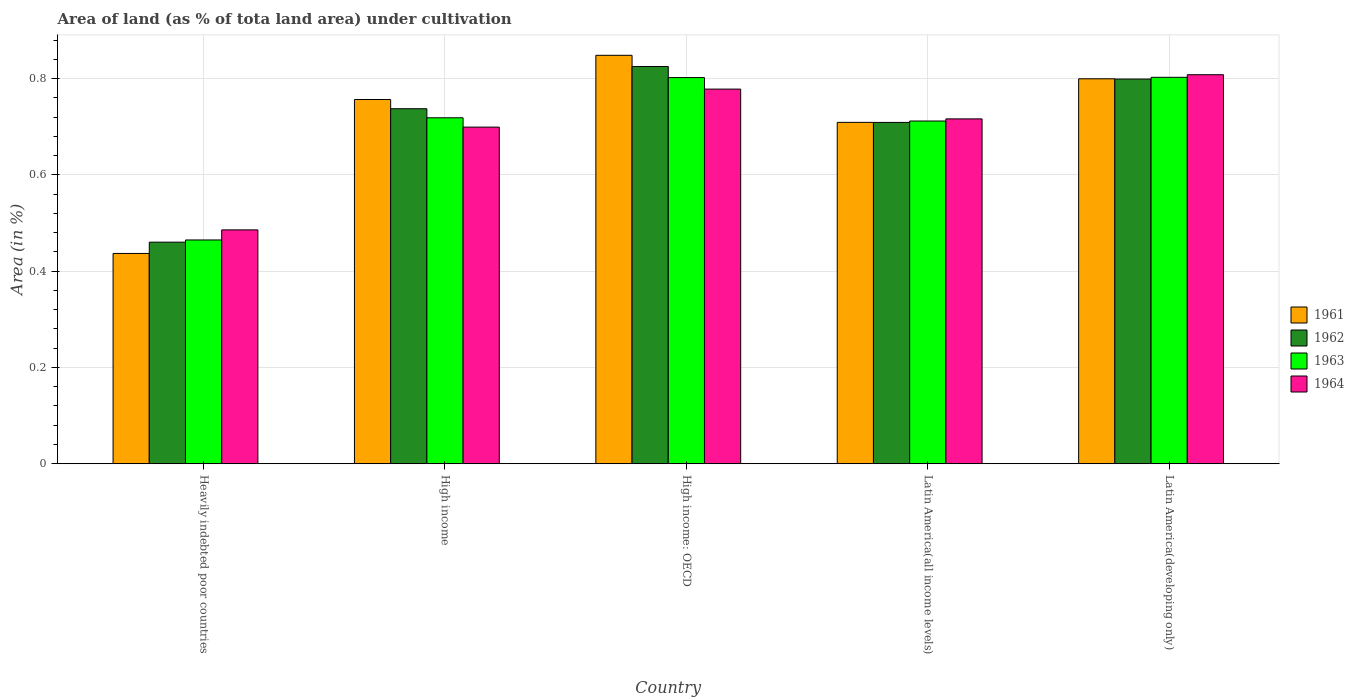How many different coloured bars are there?
Keep it short and to the point. 4. How many groups of bars are there?
Provide a short and direct response. 5. Are the number of bars on each tick of the X-axis equal?
Your answer should be very brief. Yes. What is the label of the 1st group of bars from the left?
Ensure brevity in your answer.  Heavily indebted poor countries. What is the percentage of land under cultivation in 1963 in Latin America(all income levels)?
Keep it short and to the point. 0.71. Across all countries, what is the maximum percentage of land under cultivation in 1961?
Your response must be concise. 0.85. Across all countries, what is the minimum percentage of land under cultivation in 1961?
Provide a short and direct response. 0.44. In which country was the percentage of land under cultivation in 1962 maximum?
Give a very brief answer. High income: OECD. In which country was the percentage of land under cultivation in 1961 minimum?
Offer a terse response. Heavily indebted poor countries. What is the total percentage of land under cultivation in 1961 in the graph?
Offer a very short reply. 3.55. What is the difference between the percentage of land under cultivation in 1964 in High income: OECD and that in Latin America(all income levels)?
Provide a succinct answer. 0.06. What is the difference between the percentage of land under cultivation in 1963 in High income and the percentage of land under cultivation in 1961 in Latin America(all income levels)?
Keep it short and to the point. 0.01. What is the average percentage of land under cultivation in 1963 per country?
Offer a very short reply. 0.7. What is the difference between the percentage of land under cultivation of/in 1961 and percentage of land under cultivation of/in 1962 in Latin America(all income levels)?
Provide a short and direct response. 9.965587828697497e-5. In how many countries, is the percentage of land under cultivation in 1962 greater than 0.08 %?
Provide a succinct answer. 5. What is the ratio of the percentage of land under cultivation in 1961 in Latin America(all income levels) to that in Latin America(developing only)?
Offer a very short reply. 0.89. Is the percentage of land under cultivation in 1962 in High income less than that in Latin America(developing only)?
Offer a terse response. Yes. Is the difference between the percentage of land under cultivation in 1961 in Heavily indebted poor countries and High income greater than the difference between the percentage of land under cultivation in 1962 in Heavily indebted poor countries and High income?
Give a very brief answer. No. What is the difference between the highest and the second highest percentage of land under cultivation in 1963?
Keep it short and to the point. 0. What is the difference between the highest and the lowest percentage of land under cultivation in 1963?
Make the answer very short. 0.34. What does the 2nd bar from the left in High income: OECD represents?
Provide a succinct answer. 1962. What does the 2nd bar from the right in Latin America(developing only) represents?
Give a very brief answer. 1963. How many bars are there?
Your response must be concise. 20. Are all the bars in the graph horizontal?
Your answer should be very brief. No. How many countries are there in the graph?
Give a very brief answer. 5. What is the difference between two consecutive major ticks on the Y-axis?
Offer a terse response. 0.2. Are the values on the major ticks of Y-axis written in scientific E-notation?
Provide a succinct answer. No. Does the graph contain any zero values?
Your response must be concise. No. Does the graph contain grids?
Your answer should be very brief. Yes. Where does the legend appear in the graph?
Provide a succinct answer. Center right. How many legend labels are there?
Offer a terse response. 4. How are the legend labels stacked?
Offer a terse response. Vertical. What is the title of the graph?
Keep it short and to the point. Area of land (as % of tota land area) under cultivation. What is the label or title of the X-axis?
Ensure brevity in your answer.  Country. What is the label or title of the Y-axis?
Offer a very short reply. Area (in %). What is the Area (in %) of 1961 in Heavily indebted poor countries?
Ensure brevity in your answer.  0.44. What is the Area (in %) in 1962 in Heavily indebted poor countries?
Your answer should be compact. 0.46. What is the Area (in %) in 1963 in Heavily indebted poor countries?
Make the answer very short. 0.46. What is the Area (in %) of 1964 in Heavily indebted poor countries?
Make the answer very short. 0.49. What is the Area (in %) in 1961 in High income?
Offer a very short reply. 0.76. What is the Area (in %) in 1962 in High income?
Provide a succinct answer. 0.74. What is the Area (in %) in 1963 in High income?
Make the answer very short. 0.72. What is the Area (in %) in 1964 in High income?
Ensure brevity in your answer.  0.7. What is the Area (in %) of 1961 in High income: OECD?
Make the answer very short. 0.85. What is the Area (in %) in 1962 in High income: OECD?
Offer a very short reply. 0.83. What is the Area (in %) of 1963 in High income: OECD?
Keep it short and to the point. 0.8. What is the Area (in %) in 1964 in High income: OECD?
Keep it short and to the point. 0.78. What is the Area (in %) in 1961 in Latin America(all income levels)?
Give a very brief answer. 0.71. What is the Area (in %) of 1962 in Latin America(all income levels)?
Provide a succinct answer. 0.71. What is the Area (in %) in 1963 in Latin America(all income levels)?
Your answer should be compact. 0.71. What is the Area (in %) of 1964 in Latin America(all income levels)?
Your response must be concise. 0.72. What is the Area (in %) of 1961 in Latin America(developing only)?
Provide a succinct answer. 0.8. What is the Area (in %) in 1962 in Latin America(developing only)?
Make the answer very short. 0.8. What is the Area (in %) of 1963 in Latin America(developing only)?
Ensure brevity in your answer.  0.8. What is the Area (in %) of 1964 in Latin America(developing only)?
Offer a very short reply. 0.81. Across all countries, what is the maximum Area (in %) of 1961?
Your answer should be very brief. 0.85. Across all countries, what is the maximum Area (in %) of 1962?
Your answer should be very brief. 0.83. Across all countries, what is the maximum Area (in %) in 1963?
Your response must be concise. 0.8. Across all countries, what is the maximum Area (in %) of 1964?
Offer a terse response. 0.81. Across all countries, what is the minimum Area (in %) of 1961?
Your answer should be very brief. 0.44. Across all countries, what is the minimum Area (in %) of 1962?
Offer a terse response. 0.46. Across all countries, what is the minimum Area (in %) of 1963?
Ensure brevity in your answer.  0.46. Across all countries, what is the minimum Area (in %) in 1964?
Offer a very short reply. 0.49. What is the total Area (in %) in 1961 in the graph?
Ensure brevity in your answer.  3.55. What is the total Area (in %) in 1962 in the graph?
Make the answer very short. 3.53. What is the total Area (in %) in 1964 in the graph?
Offer a terse response. 3.49. What is the difference between the Area (in %) of 1961 in Heavily indebted poor countries and that in High income?
Your answer should be very brief. -0.32. What is the difference between the Area (in %) of 1962 in Heavily indebted poor countries and that in High income?
Make the answer very short. -0.28. What is the difference between the Area (in %) in 1963 in Heavily indebted poor countries and that in High income?
Your answer should be very brief. -0.25. What is the difference between the Area (in %) in 1964 in Heavily indebted poor countries and that in High income?
Your answer should be compact. -0.21. What is the difference between the Area (in %) in 1961 in Heavily indebted poor countries and that in High income: OECD?
Ensure brevity in your answer.  -0.41. What is the difference between the Area (in %) in 1962 in Heavily indebted poor countries and that in High income: OECD?
Offer a very short reply. -0.36. What is the difference between the Area (in %) in 1963 in Heavily indebted poor countries and that in High income: OECD?
Make the answer very short. -0.34. What is the difference between the Area (in %) in 1964 in Heavily indebted poor countries and that in High income: OECD?
Ensure brevity in your answer.  -0.29. What is the difference between the Area (in %) in 1961 in Heavily indebted poor countries and that in Latin America(all income levels)?
Offer a very short reply. -0.27. What is the difference between the Area (in %) of 1962 in Heavily indebted poor countries and that in Latin America(all income levels)?
Offer a terse response. -0.25. What is the difference between the Area (in %) of 1963 in Heavily indebted poor countries and that in Latin America(all income levels)?
Provide a succinct answer. -0.25. What is the difference between the Area (in %) in 1964 in Heavily indebted poor countries and that in Latin America(all income levels)?
Offer a very short reply. -0.23. What is the difference between the Area (in %) of 1961 in Heavily indebted poor countries and that in Latin America(developing only)?
Offer a very short reply. -0.36. What is the difference between the Area (in %) in 1962 in Heavily indebted poor countries and that in Latin America(developing only)?
Your answer should be very brief. -0.34. What is the difference between the Area (in %) in 1963 in Heavily indebted poor countries and that in Latin America(developing only)?
Provide a succinct answer. -0.34. What is the difference between the Area (in %) in 1964 in Heavily indebted poor countries and that in Latin America(developing only)?
Make the answer very short. -0.32. What is the difference between the Area (in %) of 1961 in High income and that in High income: OECD?
Keep it short and to the point. -0.09. What is the difference between the Area (in %) of 1962 in High income and that in High income: OECD?
Ensure brevity in your answer.  -0.09. What is the difference between the Area (in %) in 1963 in High income and that in High income: OECD?
Your answer should be very brief. -0.08. What is the difference between the Area (in %) of 1964 in High income and that in High income: OECD?
Provide a succinct answer. -0.08. What is the difference between the Area (in %) in 1961 in High income and that in Latin America(all income levels)?
Offer a terse response. 0.05. What is the difference between the Area (in %) of 1962 in High income and that in Latin America(all income levels)?
Keep it short and to the point. 0.03. What is the difference between the Area (in %) of 1963 in High income and that in Latin America(all income levels)?
Your response must be concise. 0.01. What is the difference between the Area (in %) of 1964 in High income and that in Latin America(all income levels)?
Your answer should be compact. -0.02. What is the difference between the Area (in %) in 1961 in High income and that in Latin America(developing only)?
Offer a terse response. -0.04. What is the difference between the Area (in %) in 1962 in High income and that in Latin America(developing only)?
Offer a terse response. -0.06. What is the difference between the Area (in %) of 1963 in High income and that in Latin America(developing only)?
Your response must be concise. -0.08. What is the difference between the Area (in %) in 1964 in High income and that in Latin America(developing only)?
Provide a short and direct response. -0.11. What is the difference between the Area (in %) in 1961 in High income: OECD and that in Latin America(all income levels)?
Offer a very short reply. 0.14. What is the difference between the Area (in %) of 1962 in High income: OECD and that in Latin America(all income levels)?
Give a very brief answer. 0.12. What is the difference between the Area (in %) in 1963 in High income: OECD and that in Latin America(all income levels)?
Your response must be concise. 0.09. What is the difference between the Area (in %) in 1964 in High income: OECD and that in Latin America(all income levels)?
Ensure brevity in your answer.  0.06. What is the difference between the Area (in %) of 1961 in High income: OECD and that in Latin America(developing only)?
Provide a succinct answer. 0.05. What is the difference between the Area (in %) of 1962 in High income: OECD and that in Latin America(developing only)?
Offer a terse response. 0.03. What is the difference between the Area (in %) of 1963 in High income: OECD and that in Latin America(developing only)?
Ensure brevity in your answer.  -0. What is the difference between the Area (in %) in 1964 in High income: OECD and that in Latin America(developing only)?
Provide a short and direct response. -0.03. What is the difference between the Area (in %) in 1961 in Latin America(all income levels) and that in Latin America(developing only)?
Ensure brevity in your answer.  -0.09. What is the difference between the Area (in %) in 1962 in Latin America(all income levels) and that in Latin America(developing only)?
Offer a terse response. -0.09. What is the difference between the Area (in %) in 1963 in Latin America(all income levels) and that in Latin America(developing only)?
Make the answer very short. -0.09. What is the difference between the Area (in %) of 1964 in Latin America(all income levels) and that in Latin America(developing only)?
Give a very brief answer. -0.09. What is the difference between the Area (in %) of 1961 in Heavily indebted poor countries and the Area (in %) of 1962 in High income?
Your answer should be compact. -0.3. What is the difference between the Area (in %) of 1961 in Heavily indebted poor countries and the Area (in %) of 1963 in High income?
Provide a succinct answer. -0.28. What is the difference between the Area (in %) in 1961 in Heavily indebted poor countries and the Area (in %) in 1964 in High income?
Your answer should be compact. -0.26. What is the difference between the Area (in %) in 1962 in Heavily indebted poor countries and the Area (in %) in 1963 in High income?
Offer a terse response. -0.26. What is the difference between the Area (in %) in 1962 in Heavily indebted poor countries and the Area (in %) in 1964 in High income?
Provide a short and direct response. -0.24. What is the difference between the Area (in %) in 1963 in Heavily indebted poor countries and the Area (in %) in 1964 in High income?
Your answer should be very brief. -0.23. What is the difference between the Area (in %) of 1961 in Heavily indebted poor countries and the Area (in %) of 1962 in High income: OECD?
Offer a very short reply. -0.39. What is the difference between the Area (in %) in 1961 in Heavily indebted poor countries and the Area (in %) in 1963 in High income: OECD?
Provide a short and direct response. -0.37. What is the difference between the Area (in %) of 1961 in Heavily indebted poor countries and the Area (in %) of 1964 in High income: OECD?
Your response must be concise. -0.34. What is the difference between the Area (in %) of 1962 in Heavily indebted poor countries and the Area (in %) of 1963 in High income: OECD?
Your answer should be very brief. -0.34. What is the difference between the Area (in %) in 1962 in Heavily indebted poor countries and the Area (in %) in 1964 in High income: OECD?
Keep it short and to the point. -0.32. What is the difference between the Area (in %) of 1963 in Heavily indebted poor countries and the Area (in %) of 1964 in High income: OECD?
Your response must be concise. -0.31. What is the difference between the Area (in %) of 1961 in Heavily indebted poor countries and the Area (in %) of 1962 in Latin America(all income levels)?
Make the answer very short. -0.27. What is the difference between the Area (in %) in 1961 in Heavily indebted poor countries and the Area (in %) in 1963 in Latin America(all income levels)?
Your response must be concise. -0.28. What is the difference between the Area (in %) in 1961 in Heavily indebted poor countries and the Area (in %) in 1964 in Latin America(all income levels)?
Keep it short and to the point. -0.28. What is the difference between the Area (in %) of 1962 in Heavily indebted poor countries and the Area (in %) of 1963 in Latin America(all income levels)?
Ensure brevity in your answer.  -0.25. What is the difference between the Area (in %) of 1962 in Heavily indebted poor countries and the Area (in %) of 1964 in Latin America(all income levels)?
Provide a succinct answer. -0.26. What is the difference between the Area (in %) of 1963 in Heavily indebted poor countries and the Area (in %) of 1964 in Latin America(all income levels)?
Offer a very short reply. -0.25. What is the difference between the Area (in %) of 1961 in Heavily indebted poor countries and the Area (in %) of 1962 in Latin America(developing only)?
Provide a succinct answer. -0.36. What is the difference between the Area (in %) in 1961 in Heavily indebted poor countries and the Area (in %) in 1963 in Latin America(developing only)?
Your response must be concise. -0.37. What is the difference between the Area (in %) in 1961 in Heavily indebted poor countries and the Area (in %) in 1964 in Latin America(developing only)?
Your answer should be very brief. -0.37. What is the difference between the Area (in %) in 1962 in Heavily indebted poor countries and the Area (in %) in 1963 in Latin America(developing only)?
Offer a terse response. -0.34. What is the difference between the Area (in %) of 1962 in Heavily indebted poor countries and the Area (in %) of 1964 in Latin America(developing only)?
Your answer should be very brief. -0.35. What is the difference between the Area (in %) in 1963 in Heavily indebted poor countries and the Area (in %) in 1964 in Latin America(developing only)?
Provide a short and direct response. -0.34. What is the difference between the Area (in %) in 1961 in High income and the Area (in %) in 1962 in High income: OECD?
Ensure brevity in your answer.  -0.07. What is the difference between the Area (in %) of 1961 in High income and the Area (in %) of 1963 in High income: OECD?
Ensure brevity in your answer.  -0.05. What is the difference between the Area (in %) of 1961 in High income and the Area (in %) of 1964 in High income: OECD?
Your answer should be compact. -0.02. What is the difference between the Area (in %) of 1962 in High income and the Area (in %) of 1963 in High income: OECD?
Offer a very short reply. -0.06. What is the difference between the Area (in %) of 1962 in High income and the Area (in %) of 1964 in High income: OECD?
Make the answer very short. -0.04. What is the difference between the Area (in %) in 1963 in High income and the Area (in %) in 1964 in High income: OECD?
Give a very brief answer. -0.06. What is the difference between the Area (in %) in 1961 in High income and the Area (in %) in 1962 in Latin America(all income levels)?
Offer a very short reply. 0.05. What is the difference between the Area (in %) in 1961 in High income and the Area (in %) in 1963 in Latin America(all income levels)?
Make the answer very short. 0.04. What is the difference between the Area (in %) in 1961 in High income and the Area (in %) in 1964 in Latin America(all income levels)?
Make the answer very short. 0.04. What is the difference between the Area (in %) of 1962 in High income and the Area (in %) of 1963 in Latin America(all income levels)?
Ensure brevity in your answer.  0.03. What is the difference between the Area (in %) of 1962 in High income and the Area (in %) of 1964 in Latin America(all income levels)?
Offer a terse response. 0.02. What is the difference between the Area (in %) in 1963 in High income and the Area (in %) in 1964 in Latin America(all income levels)?
Ensure brevity in your answer.  0. What is the difference between the Area (in %) in 1961 in High income and the Area (in %) in 1962 in Latin America(developing only)?
Ensure brevity in your answer.  -0.04. What is the difference between the Area (in %) of 1961 in High income and the Area (in %) of 1963 in Latin America(developing only)?
Your answer should be compact. -0.05. What is the difference between the Area (in %) in 1961 in High income and the Area (in %) in 1964 in Latin America(developing only)?
Make the answer very short. -0.05. What is the difference between the Area (in %) of 1962 in High income and the Area (in %) of 1963 in Latin America(developing only)?
Give a very brief answer. -0.07. What is the difference between the Area (in %) in 1962 in High income and the Area (in %) in 1964 in Latin America(developing only)?
Give a very brief answer. -0.07. What is the difference between the Area (in %) of 1963 in High income and the Area (in %) of 1964 in Latin America(developing only)?
Give a very brief answer. -0.09. What is the difference between the Area (in %) in 1961 in High income: OECD and the Area (in %) in 1962 in Latin America(all income levels)?
Give a very brief answer. 0.14. What is the difference between the Area (in %) of 1961 in High income: OECD and the Area (in %) of 1963 in Latin America(all income levels)?
Your answer should be very brief. 0.14. What is the difference between the Area (in %) in 1961 in High income: OECD and the Area (in %) in 1964 in Latin America(all income levels)?
Offer a terse response. 0.13. What is the difference between the Area (in %) of 1962 in High income: OECD and the Area (in %) of 1963 in Latin America(all income levels)?
Your answer should be compact. 0.11. What is the difference between the Area (in %) in 1962 in High income: OECD and the Area (in %) in 1964 in Latin America(all income levels)?
Your answer should be compact. 0.11. What is the difference between the Area (in %) in 1963 in High income: OECD and the Area (in %) in 1964 in Latin America(all income levels)?
Make the answer very short. 0.09. What is the difference between the Area (in %) of 1961 in High income: OECD and the Area (in %) of 1962 in Latin America(developing only)?
Give a very brief answer. 0.05. What is the difference between the Area (in %) in 1961 in High income: OECD and the Area (in %) in 1963 in Latin America(developing only)?
Provide a short and direct response. 0.05. What is the difference between the Area (in %) of 1961 in High income: OECD and the Area (in %) of 1964 in Latin America(developing only)?
Your answer should be very brief. 0.04. What is the difference between the Area (in %) in 1962 in High income: OECD and the Area (in %) in 1963 in Latin America(developing only)?
Give a very brief answer. 0.02. What is the difference between the Area (in %) in 1962 in High income: OECD and the Area (in %) in 1964 in Latin America(developing only)?
Your answer should be very brief. 0.02. What is the difference between the Area (in %) of 1963 in High income: OECD and the Area (in %) of 1964 in Latin America(developing only)?
Your answer should be compact. -0.01. What is the difference between the Area (in %) of 1961 in Latin America(all income levels) and the Area (in %) of 1962 in Latin America(developing only)?
Provide a short and direct response. -0.09. What is the difference between the Area (in %) in 1961 in Latin America(all income levels) and the Area (in %) in 1963 in Latin America(developing only)?
Give a very brief answer. -0.09. What is the difference between the Area (in %) of 1961 in Latin America(all income levels) and the Area (in %) of 1964 in Latin America(developing only)?
Provide a short and direct response. -0.1. What is the difference between the Area (in %) in 1962 in Latin America(all income levels) and the Area (in %) in 1963 in Latin America(developing only)?
Keep it short and to the point. -0.09. What is the difference between the Area (in %) in 1962 in Latin America(all income levels) and the Area (in %) in 1964 in Latin America(developing only)?
Offer a terse response. -0.1. What is the difference between the Area (in %) of 1963 in Latin America(all income levels) and the Area (in %) of 1964 in Latin America(developing only)?
Your answer should be compact. -0.1. What is the average Area (in %) in 1961 per country?
Provide a succinct answer. 0.71. What is the average Area (in %) in 1962 per country?
Offer a very short reply. 0.71. What is the average Area (in %) of 1964 per country?
Your answer should be very brief. 0.7. What is the difference between the Area (in %) in 1961 and Area (in %) in 1962 in Heavily indebted poor countries?
Keep it short and to the point. -0.02. What is the difference between the Area (in %) of 1961 and Area (in %) of 1963 in Heavily indebted poor countries?
Give a very brief answer. -0.03. What is the difference between the Area (in %) in 1961 and Area (in %) in 1964 in Heavily indebted poor countries?
Keep it short and to the point. -0.05. What is the difference between the Area (in %) in 1962 and Area (in %) in 1963 in Heavily indebted poor countries?
Your answer should be very brief. -0. What is the difference between the Area (in %) of 1962 and Area (in %) of 1964 in Heavily indebted poor countries?
Keep it short and to the point. -0.03. What is the difference between the Area (in %) of 1963 and Area (in %) of 1964 in Heavily indebted poor countries?
Provide a succinct answer. -0.02. What is the difference between the Area (in %) of 1961 and Area (in %) of 1962 in High income?
Offer a terse response. 0.02. What is the difference between the Area (in %) of 1961 and Area (in %) of 1963 in High income?
Offer a terse response. 0.04. What is the difference between the Area (in %) in 1961 and Area (in %) in 1964 in High income?
Your response must be concise. 0.06. What is the difference between the Area (in %) in 1962 and Area (in %) in 1963 in High income?
Give a very brief answer. 0.02. What is the difference between the Area (in %) in 1962 and Area (in %) in 1964 in High income?
Your response must be concise. 0.04. What is the difference between the Area (in %) of 1963 and Area (in %) of 1964 in High income?
Keep it short and to the point. 0.02. What is the difference between the Area (in %) in 1961 and Area (in %) in 1962 in High income: OECD?
Give a very brief answer. 0.02. What is the difference between the Area (in %) of 1961 and Area (in %) of 1963 in High income: OECD?
Provide a succinct answer. 0.05. What is the difference between the Area (in %) of 1961 and Area (in %) of 1964 in High income: OECD?
Keep it short and to the point. 0.07. What is the difference between the Area (in %) in 1962 and Area (in %) in 1963 in High income: OECD?
Provide a succinct answer. 0.02. What is the difference between the Area (in %) in 1962 and Area (in %) in 1964 in High income: OECD?
Make the answer very short. 0.05. What is the difference between the Area (in %) in 1963 and Area (in %) in 1964 in High income: OECD?
Provide a succinct answer. 0.02. What is the difference between the Area (in %) in 1961 and Area (in %) in 1963 in Latin America(all income levels)?
Offer a terse response. -0. What is the difference between the Area (in %) in 1961 and Area (in %) in 1964 in Latin America(all income levels)?
Keep it short and to the point. -0.01. What is the difference between the Area (in %) in 1962 and Area (in %) in 1963 in Latin America(all income levels)?
Give a very brief answer. -0. What is the difference between the Area (in %) of 1962 and Area (in %) of 1964 in Latin America(all income levels)?
Keep it short and to the point. -0.01. What is the difference between the Area (in %) in 1963 and Area (in %) in 1964 in Latin America(all income levels)?
Keep it short and to the point. -0. What is the difference between the Area (in %) in 1961 and Area (in %) in 1962 in Latin America(developing only)?
Offer a terse response. 0. What is the difference between the Area (in %) of 1961 and Area (in %) of 1963 in Latin America(developing only)?
Your answer should be compact. -0. What is the difference between the Area (in %) in 1961 and Area (in %) in 1964 in Latin America(developing only)?
Provide a succinct answer. -0.01. What is the difference between the Area (in %) in 1962 and Area (in %) in 1963 in Latin America(developing only)?
Your answer should be very brief. -0. What is the difference between the Area (in %) of 1962 and Area (in %) of 1964 in Latin America(developing only)?
Offer a terse response. -0.01. What is the difference between the Area (in %) of 1963 and Area (in %) of 1964 in Latin America(developing only)?
Give a very brief answer. -0.01. What is the ratio of the Area (in %) of 1961 in Heavily indebted poor countries to that in High income?
Give a very brief answer. 0.58. What is the ratio of the Area (in %) of 1962 in Heavily indebted poor countries to that in High income?
Give a very brief answer. 0.62. What is the ratio of the Area (in %) of 1963 in Heavily indebted poor countries to that in High income?
Make the answer very short. 0.65. What is the ratio of the Area (in %) of 1964 in Heavily indebted poor countries to that in High income?
Make the answer very short. 0.69. What is the ratio of the Area (in %) in 1961 in Heavily indebted poor countries to that in High income: OECD?
Your answer should be very brief. 0.51. What is the ratio of the Area (in %) of 1962 in Heavily indebted poor countries to that in High income: OECD?
Provide a short and direct response. 0.56. What is the ratio of the Area (in %) in 1963 in Heavily indebted poor countries to that in High income: OECD?
Make the answer very short. 0.58. What is the ratio of the Area (in %) of 1964 in Heavily indebted poor countries to that in High income: OECD?
Offer a very short reply. 0.62. What is the ratio of the Area (in %) of 1961 in Heavily indebted poor countries to that in Latin America(all income levels)?
Your answer should be very brief. 0.62. What is the ratio of the Area (in %) in 1962 in Heavily indebted poor countries to that in Latin America(all income levels)?
Provide a succinct answer. 0.65. What is the ratio of the Area (in %) of 1963 in Heavily indebted poor countries to that in Latin America(all income levels)?
Make the answer very short. 0.65. What is the ratio of the Area (in %) of 1964 in Heavily indebted poor countries to that in Latin America(all income levels)?
Give a very brief answer. 0.68. What is the ratio of the Area (in %) of 1961 in Heavily indebted poor countries to that in Latin America(developing only)?
Provide a short and direct response. 0.55. What is the ratio of the Area (in %) in 1962 in Heavily indebted poor countries to that in Latin America(developing only)?
Provide a succinct answer. 0.58. What is the ratio of the Area (in %) in 1963 in Heavily indebted poor countries to that in Latin America(developing only)?
Give a very brief answer. 0.58. What is the ratio of the Area (in %) of 1964 in Heavily indebted poor countries to that in Latin America(developing only)?
Provide a succinct answer. 0.6. What is the ratio of the Area (in %) in 1961 in High income to that in High income: OECD?
Offer a very short reply. 0.89. What is the ratio of the Area (in %) in 1962 in High income to that in High income: OECD?
Your response must be concise. 0.89. What is the ratio of the Area (in %) in 1963 in High income to that in High income: OECD?
Provide a succinct answer. 0.9. What is the ratio of the Area (in %) in 1964 in High income to that in High income: OECD?
Make the answer very short. 0.9. What is the ratio of the Area (in %) of 1961 in High income to that in Latin America(all income levels)?
Make the answer very short. 1.07. What is the ratio of the Area (in %) of 1962 in High income to that in Latin America(all income levels)?
Ensure brevity in your answer.  1.04. What is the ratio of the Area (in %) of 1963 in High income to that in Latin America(all income levels)?
Ensure brevity in your answer.  1.01. What is the ratio of the Area (in %) in 1964 in High income to that in Latin America(all income levels)?
Offer a terse response. 0.98. What is the ratio of the Area (in %) of 1961 in High income to that in Latin America(developing only)?
Offer a terse response. 0.95. What is the ratio of the Area (in %) in 1962 in High income to that in Latin America(developing only)?
Your answer should be compact. 0.92. What is the ratio of the Area (in %) in 1963 in High income to that in Latin America(developing only)?
Offer a terse response. 0.9. What is the ratio of the Area (in %) of 1964 in High income to that in Latin America(developing only)?
Provide a succinct answer. 0.87. What is the ratio of the Area (in %) in 1961 in High income: OECD to that in Latin America(all income levels)?
Your answer should be compact. 1.2. What is the ratio of the Area (in %) in 1962 in High income: OECD to that in Latin America(all income levels)?
Ensure brevity in your answer.  1.16. What is the ratio of the Area (in %) of 1963 in High income: OECD to that in Latin America(all income levels)?
Your answer should be very brief. 1.13. What is the ratio of the Area (in %) of 1964 in High income: OECD to that in Latin America(all income levels)?
Keep it short and to the point. 1.09. What is the ratio of the Area (in %) of 1961 in High income: OECD to that in Latin America(developing only)?
Your response must be concise. 1.06. What is the ratio of the Area (in %) of 1962 in High income: OECD to that in Latin America(developing only)?
Offer a terse response. 1.03. What is the ratio of the Area (in %) in 1961 in Latin America(all income levels) to that in Latin America(developing only)?
Make the answer very short. 0.89. What is the ratio of the Area (in %) of 1962 in Latin America(all income levels) to that in Latin America(developing only)?
Give a very brief answer. 0.89. What is the ratio of the Area (in %) of 1963 in Latin America(all income levels) to that in Latin America(developing only)?
Your answer should be very brief. 0.89. What is the ratio of the Area (in %) in 1964 in Latin America(all income levels) to that in Latin America(developing only)?
Your answer should be very brief. 0.89. What is the difference between the highest and the second highest Area (in %) of 1961?
Your answer should be compact. 0.05. What is the difference between the highest and the second highest Area (in %) of 1962?
Your response must be concise. 0.03. What is the difference between the highest and the second highest Area (in %) of 1963?
Keep it short and to the point. 0. What is the difference between the highest and the second highest Area (in %) in 1964?
Your answer should be very brief. 0.03. What is the difference between the highest and the lowest Area (in %) of 1961?
Your answer should be compact. 0.41. What is the difference between the highest and the lowest Area (in %) in 1962?
Ensure brevity in your answer.  0.36. What is the difference between the highest and the lowest Area (in %) in 1963?
Your answer should be compact. 0.34. What is the difference between the highest and the lowest Area (in %) of 1964?
Provide a succinct answer. 0.32. 